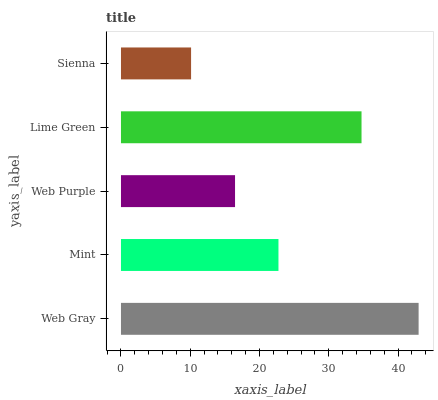Is Sienna the minimum?
Answer yes or no. Yes. Is Web Gray the maximum?
Answer yes or no. Yes. Is Mint the minimum?
Answer yes or no. No. Is Mint the maximum?
Answer yes or no. No. Is Web Gray greater than Mint?
Answer yes or no. Yes. Is Mint less than Web Gray?
Answer yes or no. Yes. Is Mint greater than Web Gray?
Answer yes or no. No. Is Web Gray less than Mint?
Answer yes or no. No. Is Mint the high median?
Answer yes or no. Yes. Is Mint the low median?
Answer yes or no. Yes. Is Web Gray the high median?
Answer yes or no. No. Is Web Gray the low median?
Answer yes or no. No. 